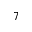<formula> <loc_0><loc_0><loc_500><loc_500>7</formula> 